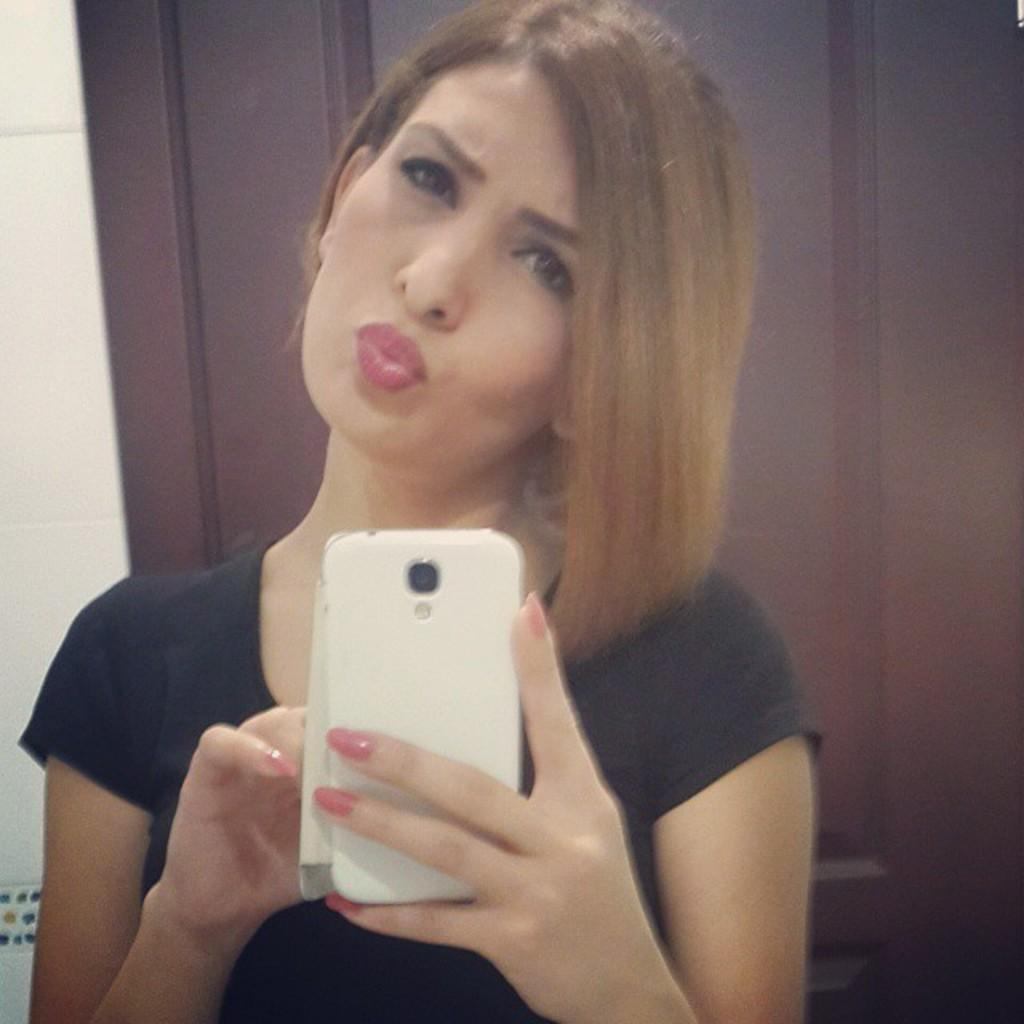What is the primary subject of the image? There is a woman in the image. What is the woman doing in the image? The woman is standing and posing for a picture. What is the woman holding in the image? The woman is holding a mobile. What is the woman wearing in the image? The woman is wearing a black t-shirt. What type of yarn is the woman using to knit in the image? There is no yarn or knitting activity present in the image. 